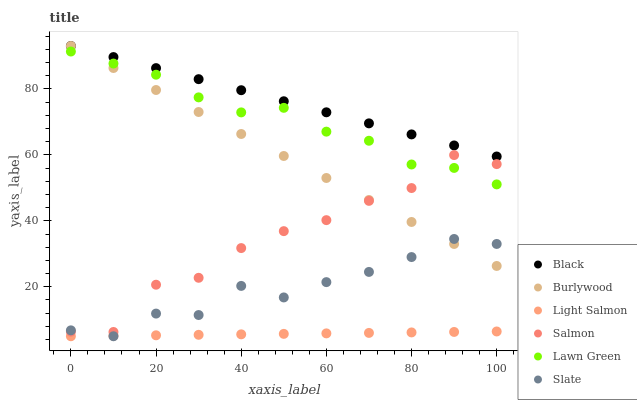Does Light Salmon have the minimum area under the curve?
Answer yes or no. Yes. Does Black have the maximum area under the curve?
Answer yes or no. Yes. Does Burlywood have the minimum area under the curve?
Answer yes or no. No. Does Burlywood have the maximum area under the curve?
Answer yes or no. No. Is Light Salmon the smoothest?
Answer yes or no. Yes. Is Salmon the roughest?
Answer yes or no. Yes. Is Burlywood the smoothest?
Answer yes or no. No. Is Burlywood the roughest?
Answer yes or no. No. Does Light Salmon have the lowest value?
Answer yes or no. Yes. Does Burlywood have the lowest value?
Answer yes or no. No. Does Black have the highest value?
Answer yes or no. Yes. Does Light Salmon have the highest value?
Answer yes or no. No. Is Light Salmon less than Black?
Answer yes or no. Yes. Is Salmon greater than Light Salmon?
Answer yes or no. Yes. Does Salmon intersect Burlywood?
Answer yes or no. Yes. Is Salmon less than Burlywood?
Answer yes or no. No. Is Salmon greater than Burlywood?
Answer yes or no. No. Does Light Salmon intersect Black?
Answer yes or no. No. 